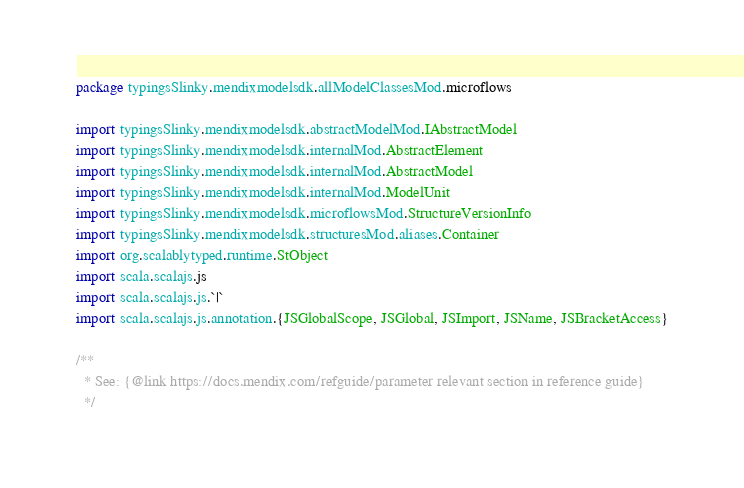<code> <loc_0><loc_0><loc_500><loc_500><_Scala_>package typingsSlinky.mendixmodelsdk.allModelClassesMod.microflows

import typingsSlinky.mendixmodelsdk.abstractModelMod.IAbstractModel
import typingsSlinky.mendixmodelsdk.internalMod.AbstractElement
import typingsSlinky.mendixmodelsdk.internalMod.AbstractModel
import typingsSlinky.mendixmodelsdk.internalMod.ModelUnit
import typingsSlinky.mendixmodelsdk.microflowsMod.StructureVersionInfo
import typingsSlinky.mendixmodelsdk.structuresMod.aliases.Container
import org.scalablytyped.runtime.StObject
import scala.scalajs.js
import scala.scalajs.js.`|`
import scala.scalajs.js.annotation.{JSGlobalScope, JSGlobal, JSImport, JSName, JSBracketAccess}

/**
  * See: {@link https://docs.mendix.com/refguide/parameter relevant section in reference guide}
  */</code> 